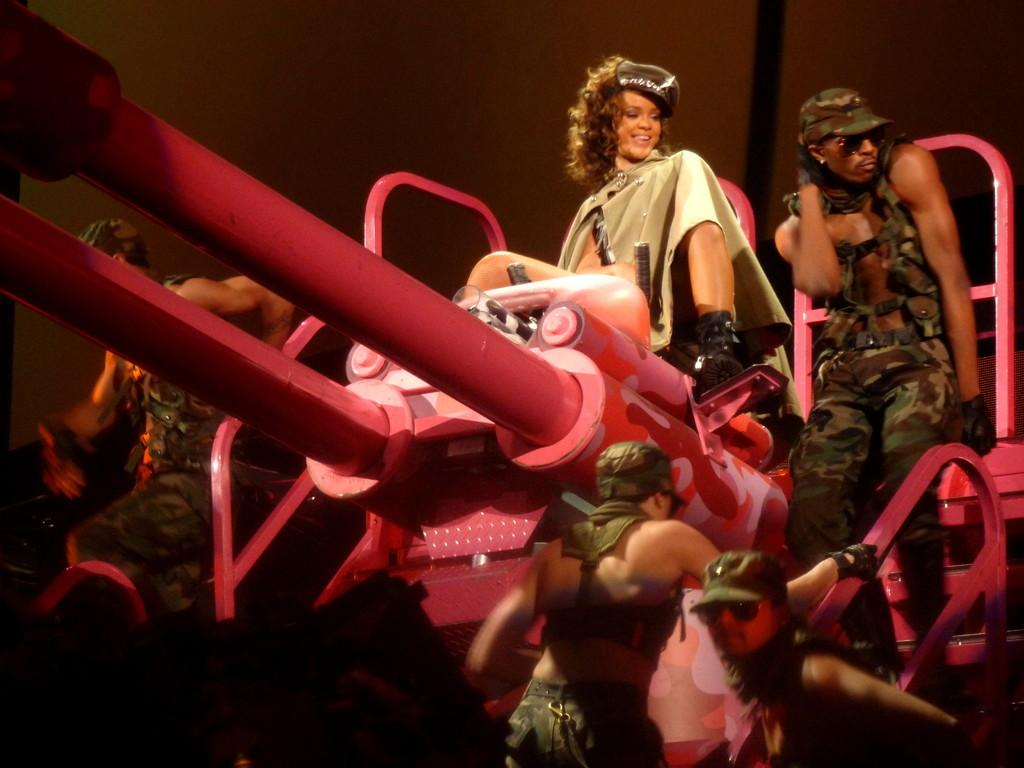What is the woman in the image doing? There is a woman sitting in the image. Can you describe the people present in the image? There are people present in the image. What type of kitty can be seen in the image? There is no kitty present in the image. What type of stew is being served in the image? There is no stew present in the image. What flavor of mint is visible in the image? There is no mint present in the image. 